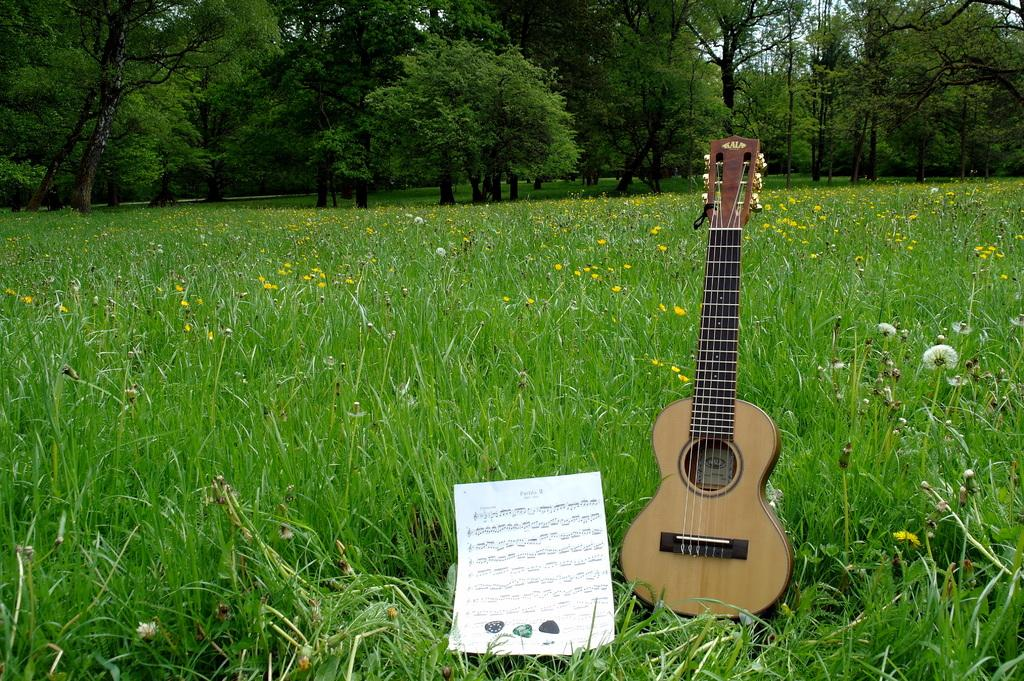Where was the image taken? The image was taken in a garden. What type of vegetation can be seen in the garden? There are trees in the garden. What is the ground covered with in the garden? The ground is covered with grass. What musical instrument is present in the garden? A musical instrument is present in the garden. Where is the musical instrument located in the garden? The musical instrument is on the floor. What other object can be seen on the floor in the garden? There is a piece of paper on the floor. What type of shirt is being used as a flame protector for the musical instrument in the image? There is no shirt or flame protector present in the image; it only features a musical instrument and a piece of paper on the floor. 